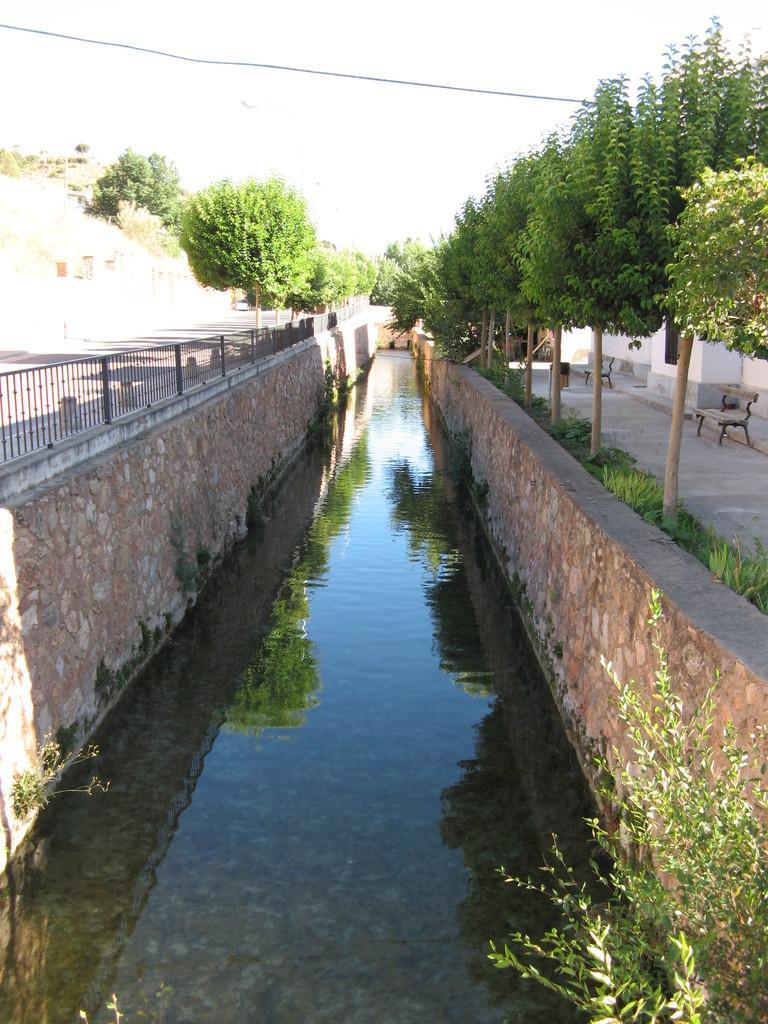In one or two sentences, can you explain what this image depicts? In this image there is a drainage beside that there is a bench on the road and building, plants. 